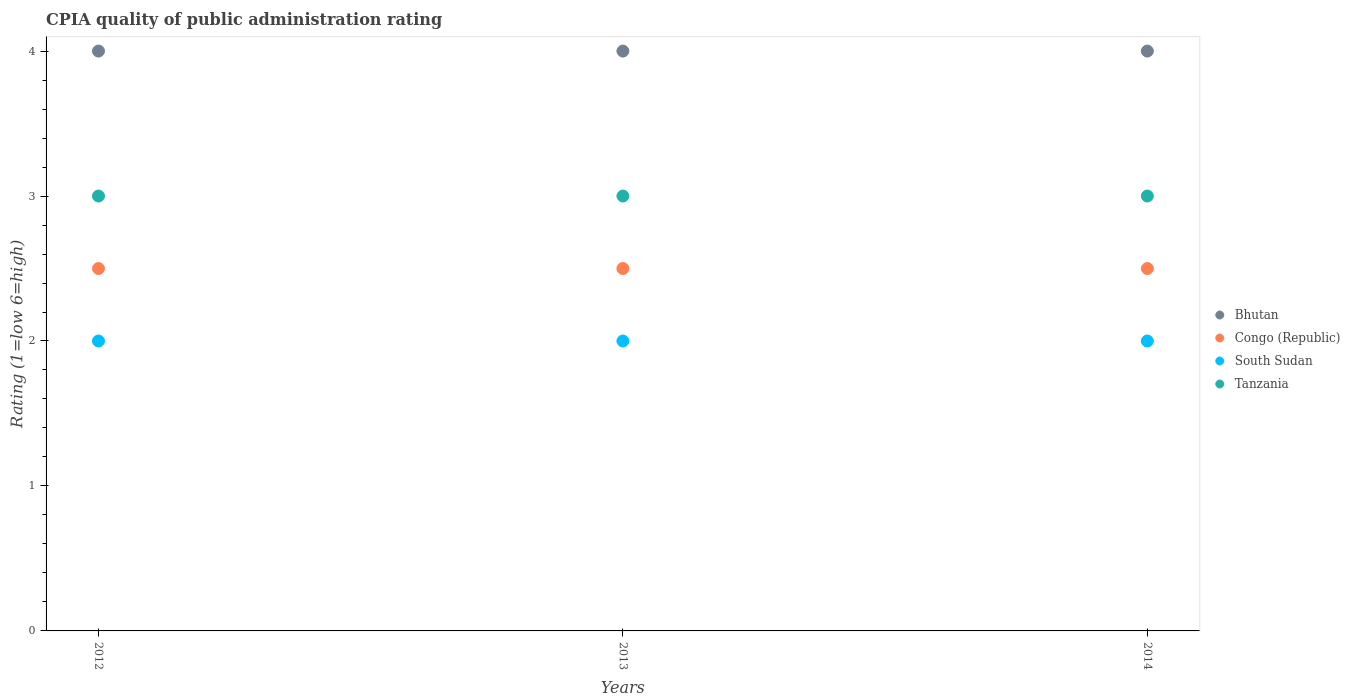How many different coloured dotlines are there?
Your response must be concise. 4. Is the number of dotlines equal to the number of legend labels?
Your answer should be very brief. Yes. What is the CPIA rating in South Sudan in 2014?
Keep it short and to the point. 2. Across all years, what is the maximum CPIA rating in Bhutan?
Offer a terse response. 4. In which year was the CPIA rating in South Sudan maximum?
Offer a terse response. 2012. In which year was the CPIA rating in Bhutan minimum?
Ensure brevity in your answer.  2012. What is the total CPIA rating in Tanzania in the graph?
Offer a very short reply. 9. What is the difference between the CPIA rating in Congo (Republic) in 2013 and that in 2014?
Provide a succinct answer. 0. What is the difference between the CPIA rating in Tanzania in 2013 and the CPIA rating in Bhutan in 2012?
Offer a very short reply. -1. In the year 2012, what is the difference between the CPIA rating in Congo (Republic) and CPIA rating in South Sudan?
Your response must be concise. 0.5. In how many years, is the CPIA rating in Bhutan greater than 2.2?
Your answer should be compact. 3. What is the ratio of the CPIA rating in Congo (Republic) in 2012 to that in 2014?
Keep it short and to the point. 1. What is the difference between the highest and the second highest CPIA rating in Congo (Republic)?
Make the answer very short. 0. Is the sum of the CPIA rating in Congo (Republic) in 2013 and 2014 greater than the maximum CPIA rating in South Sudan across all years?
Your response must be concise. Yes. Is it the case that in every year, the sum of the CPIA rating in Tanzania and CPIA rating in South Sudan  is greater than the sum of CPIA rating in Congo (Republic) and CPIA rating in Bhutan?
Give a very brief answer. Yes. Is it the case that in every year, the sum of the CPIA rating in South Sudan and CPIA rating in Bhutan  is greater than the CPIA rating in Tanzania?
Your response must be concise. Yes. Is the CPIA rating in Bhutan strictly greater than the CPIA rating in Congo (Republic) over the years?
Provide a short and direct response. Yes. Is the CPIA rating in Bhutan strictly less than the CPIA rating in South Sudan over the years?
Give a very brief answer. No. How many dotlines are there?
Ensure brevity in your answer.  4. What is the difference between two consecutive major ticks on the Y-axis?
Provide a succinct answer. 1. Does the graph contain grids?
Keep it short and to the point. No. How are the legend labels stacked?
Your answer should be compact. Vertical. What is the title of the graph?
Make the answer very short. CPIA quality of public administration rating. What is the label or title of the X-axis?
Keep it short and to the point. Years. What is the Rating (1=low 6=high) of Bhutan in 2012?
Make the answer very short. 4. What is the Rating (1=low 6=high) in Congo (Republic) in 2012?
Provide a succinct answer. 2.5. What is the Rating (1=low 6=high) in South Sudan in 2012?
Provide a short and direct response. 2. What is the Rating (1=low 6=high) of Tanzania in 2012?
Make the answer very short. 3. What is the Rating (1=low 6=high) of Bhutan in 2013?
Offer a very short reply. 4. What is the Rating (1=low 6=high) of Congo (Republic) in 2013?
Your answer should be compact. 2.5. What is the Rating (1=low 6=high) of South Sudan in 2013?
Your answer should be compact. 2. What is the Rating (1=low 6=high) in Congo (Republic) in 2014?
Provide a short and direct response. 2.5. What is the Rating (1=low 6=high) of Tanzania in 2014?
Make the answer very short. 3. Across all years, what is the maximum Rating (1=low 6=high) in South Sudan?
Provide a short and direct response. 2. Across all years, what is the maximum Rating (1=low 6=high) of Tanzania?
Offer a terse response. 3. Across all years, what is the minimum Rating (1=low 6=high) in Bhutan?
Ensure brevity in your answer.  4. Across all years, what is the minimum Rating (1=low 6=high) of Congo (Republic)?
Give a very brief answer. 2.5. Across all years, what is the minimum Rating (1=low 6=high) in South Sudan?
Provide a succinct answer. 2. Across all years, what is the minimum Rating (1=low 6=high) in Tanzania?
Make the answer very short. 3. What is the total Rating (1=low 6=high) of Bhutan in the graph?
Offer a very short reply. 12. What is the total Rating (1=low 6=high) in Congo (Republic) in the graph?
Your answer should be very brief. 7.5. What is the difference between the Rating (1=low 6=high) in Bhutan in 2012 and that in 2013?
Provide a short and direct response. 0. What is the difference between the Rating (1=low 6=high) in South Sudan in 2012 and that in 2013?
Keep it short and to the point. 0. What is the difference between the Rating (1=low 6=high) in Tanzania in 2012 and that in 2013?
Your response must be concise. 0. What is the difference between the Rating (1=low 6=high) in Bhutan in 2012 and that in 2014?
Offer a very short reply. 0. What is the difference between the Rating (1=low 6=high) in South Sudan in 2012 and that in 2014?
Keep it short and to the point. 0. What is the difference between the Rating (1=low 6=high) of Tanzania in 2012 and that in 2014?
Offer a terse response. 0. What is the difference between the Rating (1=low 6=high) in Bhutan in 2012 and the Rating (1=low 6=high) in South Sudan in 2013?
Provide a succinct answer. 2. What is the difference between the Rating (1=low 6=high) of Congo (Republic) in 2012 and the Rating (1=low 6=high) of South Sudan in 2013?
Give a very brief answer. 0.5. What is the difference between the Rating (1=low 6=high) of Bhutan in 2012 and the Rating (1=low 6=high) of Congo (Republic) in 2014?
Make the answer very short. 1.5. What is the difference between the Rating (1=low 6=high) of Bhutan in 2012 and the Rating (1=low 6=high) of South Sudan in 2014?
Provide a short and direct response. 2. What is the difference between the Rating (1=low 6=high) of Congo (Republic) in 2012 and the Rating (1=low 6=high) of South Sudan in 2014?
Offer a terse response. 0.5. What is the difference between the Rating (1=low 6=high) in Bhutan in 2013 and the Rating (1=low 6=high) in South Sudan in 2014?
Your answer should be compact. 2. What is the difference between the Rating (1=low 6=high) in Congo (Republic) in 2013 and the Rating (1=low 6=high) in Tanzania in 2014?
Your answer should be very brief. -0.5. What is the average Rating (1=low 6=high) of Congo (Republic) per year?
Ensure brevity in your answer.  2.5. What is the average Rating (1=low 6=high) in South Sudan per year?
Your answer should be very brief. 2. What is the average Rating (1=low 6=high) in Tanzania per year?
Your answer should be very brief. 3. In the year 2012, what is the difference between the Rating (1=low 6=high) in Bhutan and Rating (1=low 6=high) in Congo (Republic)?
Offer a terse response. 1.5. In the year 2012, what is the difference between the Rating (1=low 6=high) in Bhutan and Rating (1=low 6=high) in South Sudan?
Keep it short and to the point. 2. In the year 2012, what is the difference between the Rating (1=low 6=high) of Bhutan and Rating (1=low 6=high) of Tanzania?
Ensure brevity in your answer.  1. In the year 2012, what is the difference between the Rating (1=low 6=high) of Congo (Republic) and Rating (1=low 6=high) of South Sudan?
Keep it short and to the point. 0.5. In the year 2012, what is the difference between the Rating (1=low 6=high) in Congo (Republic) and Rating (1=low 6=high) in Tanzania?
Provide a short and direct response. -0.5. In the year 2013, what is the difference between the Rating (1=low 6=high) of Bhutan and Rating (1=low 6=high) of South Sudan?
Your response must be concise. 2. In the year 2013, what is the difference between the Rating (1=low 6=high) of Bhutan and Rating (1=low 6=high) of Tanzania?
Provide a short and direct response. 1. In the year 2013, what is the difference between the Rating (1=low 6=high) in South Sudan and Rating (1=low 6=high) in Tanzania?
Give a very brief answer. -1. In the year 2014, what is the difference between the Rating (1=low 6=high) in Bhutan and Rating (1=low 6=high) in South Sudan?
Your answer should be very brief. 2. In the year 2014, what is the difference between the Rating (1=low 6=high) of Congo (Republic) and Rating (1=low 6=high) of South Sudan?
Give a very brief answer. 0.5. What is the ratio of the Rating (1=low 6=high) in Congo (Republic) in 2012 to that in 2013?
Your answer should be compact. 1. What is the ratio of the Rating (1=low 6=high) in South Sudan in 2012 to that in 2013?
Offer a very short reply. 1. What is the ratio of the Rating (1=low 6=high) in Tanzania in 2012 to that in 2013?
Your response must be concise. 1. What is the ratio of the Rating (1=low 6=high) in Bhutan in 2012 to that in 2014?
Keep it short and to the point. 1. What is the ratio of the Rating (1=low 6=high) in Bhutan in 2013 to that in 2014?
Give a very brief answer. 1. What is the ratio of the Rating (1=low 6=high) in Congo (Republic) in 2013 to that in 2014?
Give a very brief answer. 1. What is the difference between the highest and the second highest Rating (1=low 6=high) in Bhutan?
Keep it short and to the point. 0. What is the difference between the highest and the second highest Rating (1=low 6=high) of Congo (Republic)?
Your response must be concise. 0. What is the difference between the highest and the lowest Rating (1=low 6=high) of Bhutan?
Give a very brief answer. 0. What is the difference between the highest and the lowest Rating (1=low 6=high) of Congo (Republic)?
Keep it short and to the point. 0. What is the difference between the highest and the lowest Rating (1=low 6=high) in South Sudan?
Your answer should be very brief. 0. 